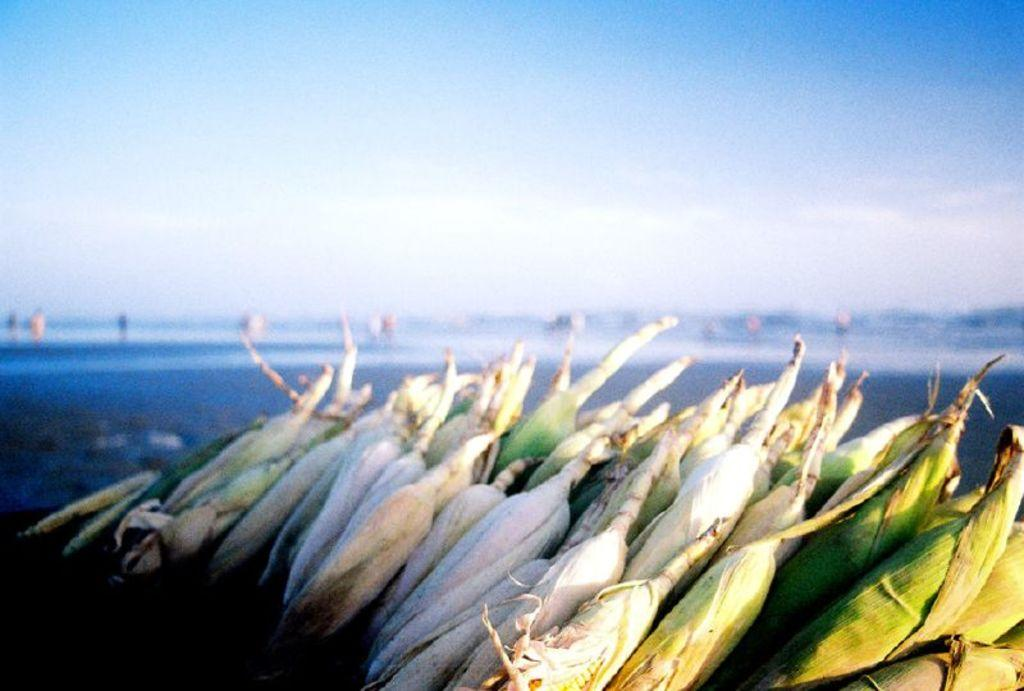What is the main subject of the image? The main subject of the image is a collection of corns arranged on a surface. What can be seen in the background of the image? In the background of the image, there are clouds in the blue sky. How is the background of the image depicted? The background of the image is blurred. What type of goat can be seen grazing near the corn in the image? There is no goat present in the image; it only features corns arranged on a surface and a blurred background with clouds in the blue sky. 